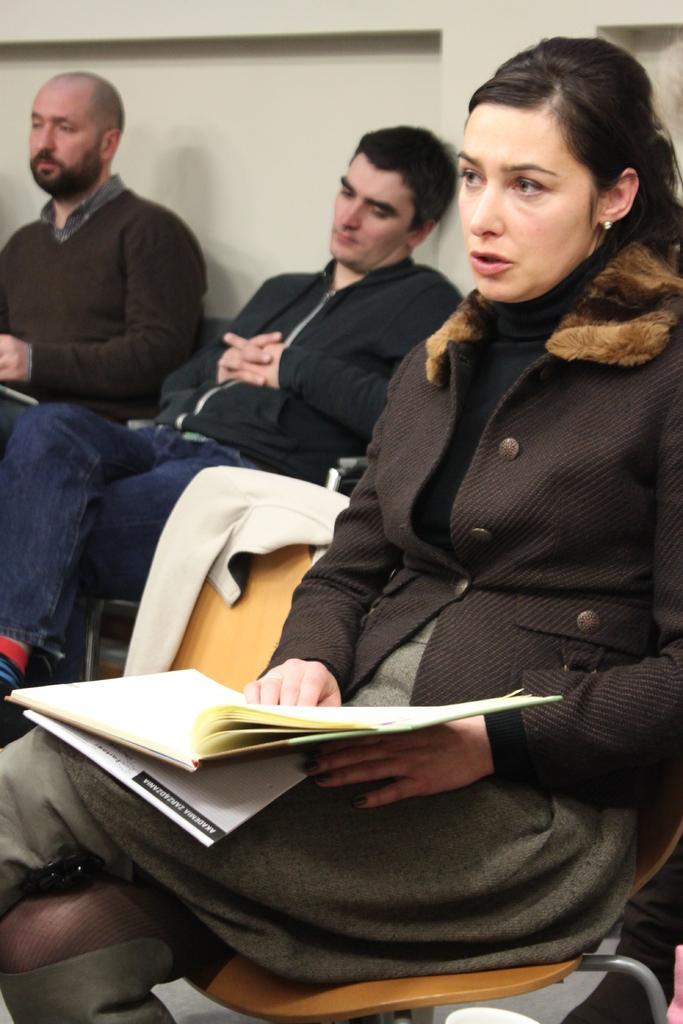Could you give a brief overview of what you see in this image? In this picture there is a woman seated in a chair holding a book in her hand, she is wearing a brown jacket. On the left there are two men seated. In the background there is a wall. 